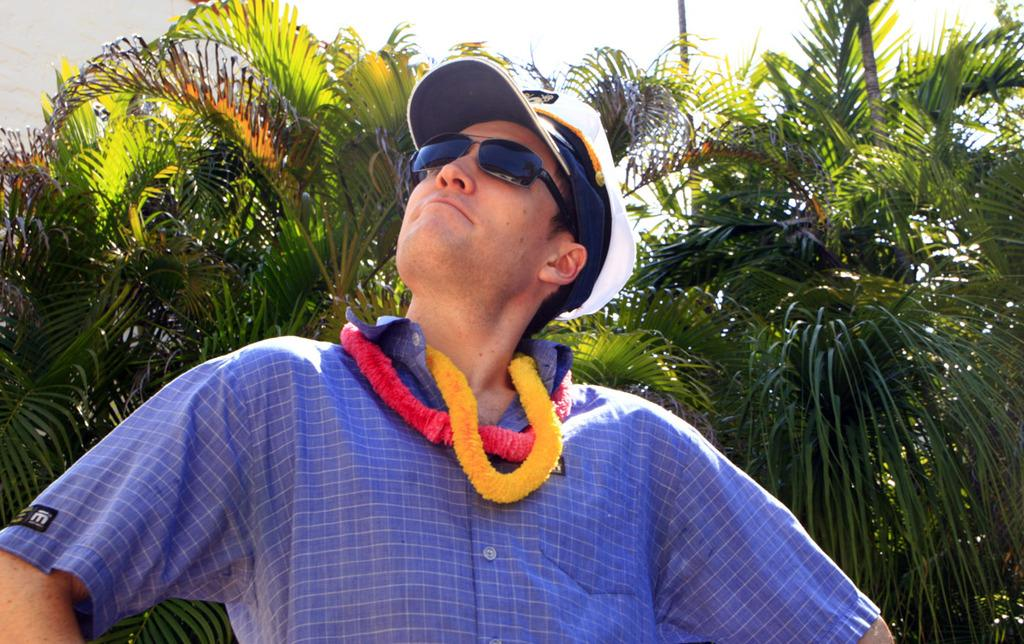Who or what is the main subject of the image? There is a person in the center of the image. What is the person wearing on their head? The person is wearing a cap. What can be seen in the distance behind the person? There are trees in the background of the image. What type of stew is being served in the image? There is no stew present in the image; it features a person wearing a cap with trees in the background. What is the person's state of mind in the image? The image does not provide any information about the person's state of mind. 